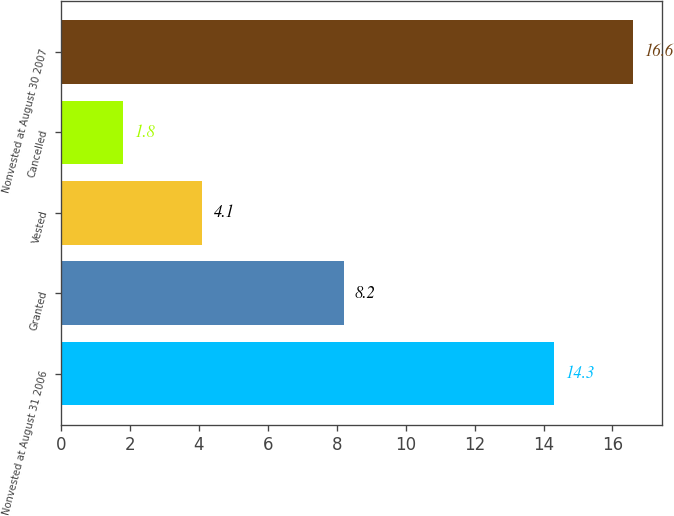Convert chart. <chart><loc_0><loc_0><loc_500><loc_500><bar_chart><fcel>Nonvested at August 31 2006<fcel>Granted<fcel>Vested<fcel>Cancelled<fcel>Nonvested at August 30 2007<nl><fcel>14.3<fcel>8.2<fcel>4.1<fcel>1.8<fcel>16.6<nl></chart> 